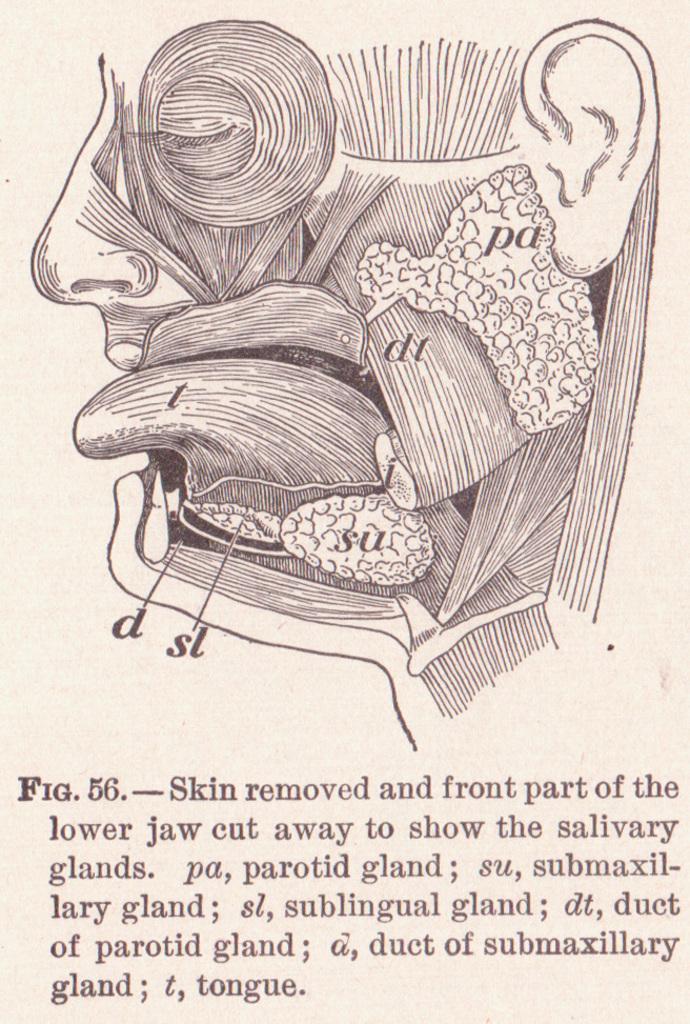Could you give a brief overview of what you see in this image? In this image, I can see the picture of the internal parts of the face. This is the paragraph below the picture. 